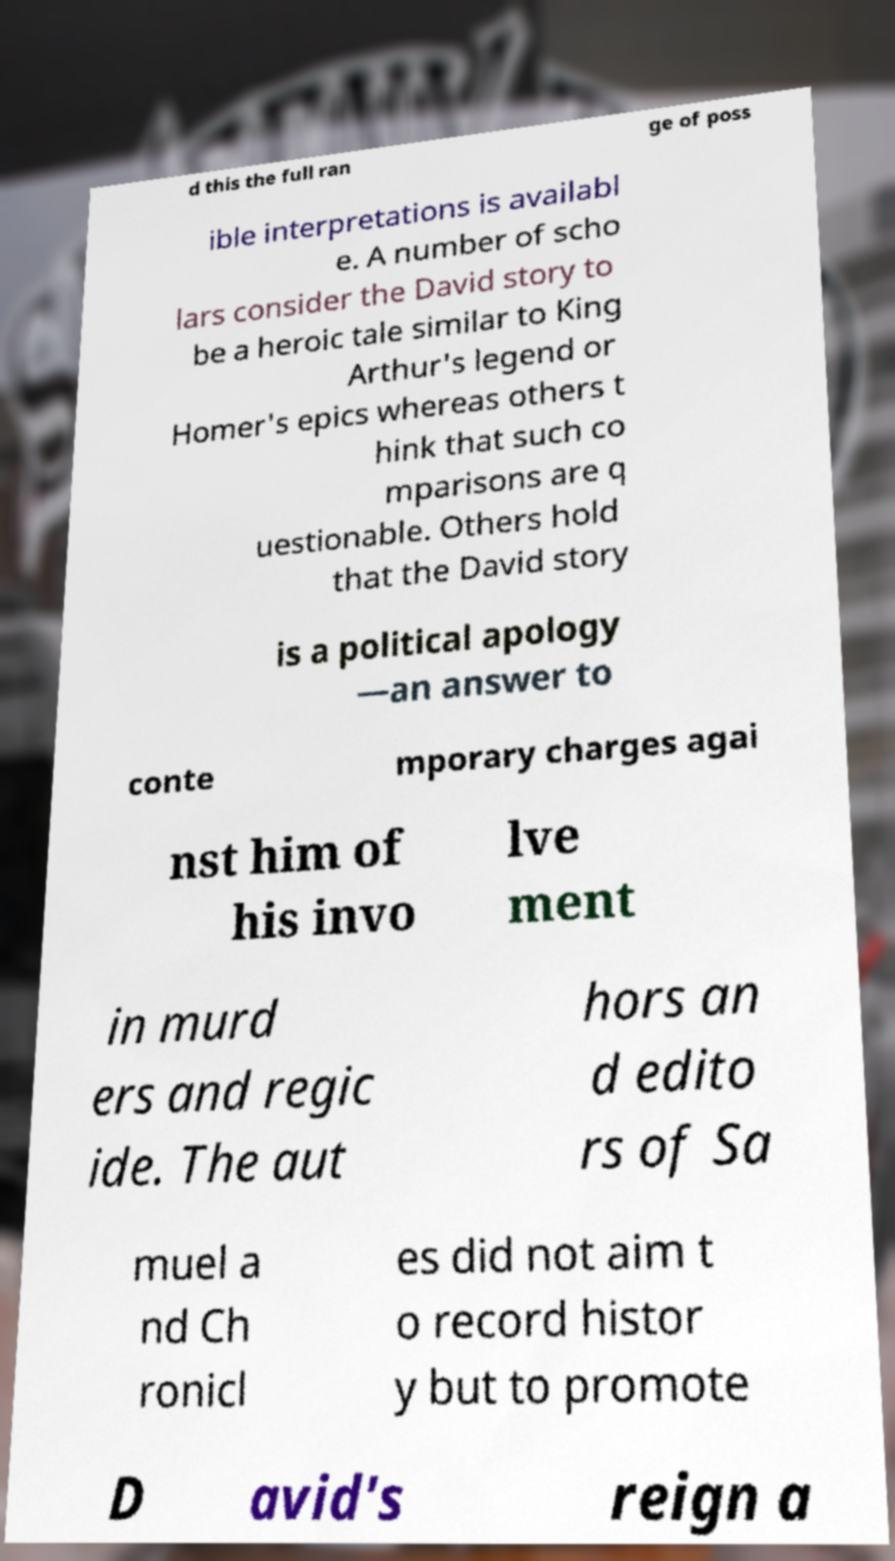Could you extract and type out the text from this image? d this the full ran ge of poss ible interpretations is availabl e. A number of scho lars consider the David story to be a heroic tale similar to King Arthur's legend or Homer's epics whereas others t hink that such co mparisons are q uestionable. Others hold that the David story is a political apology —an answer to conte mporary charges agai nst him of his invo lve ment in murd ers and regic ide. The aut hors an d edito rs of Sa muel a nd Ch ronicl es did not aim t o record histor y but to promote D avid's reign a 